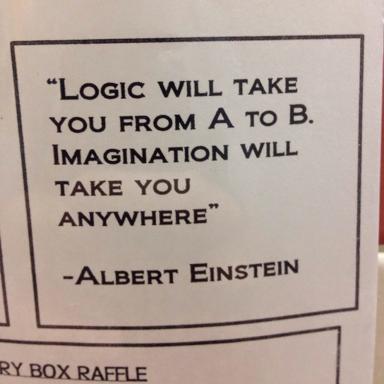What is the quote by Albert Einstein in the image? The quote by Albert Einstein in the image is "Logic will take you from A to B. Imagination will take you anywhere." Who is the author of the quote? The author of the quote is Albert Einstein. What does the quote imply about the power of imagination compared to logic? The quote implies that while logic may help you solve problems or move from one point to another in a linear fashion, imagination has the power to transcend boundaries and limitations, allowing you to explore endless possibilities and new ideas beyond the constraints of conventional thinking. 